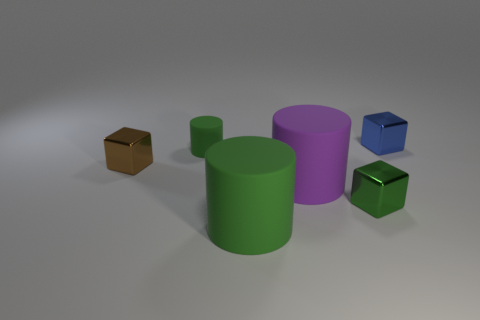Add 3 large green shiny cylinders. How many objects exist? 9 Subtract all blue blocks. Subtract all big green cylinders. How many objects are left? 4 Add 1 brown shiny cubes. How many brown shiny cubes are left? 2 Add 6 brown metal things. How many brown metal things exist? 7 Subtract 1 blue blocks. How many objects are left? 5 